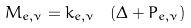Convert formula to latex. <formula><loc_0><loc_0><loc_500><loc_500>M _ { e , \nu } = k _ { e , \nu } \ \left ( \Delta + P _ { e , \nu } \right )</formula> 